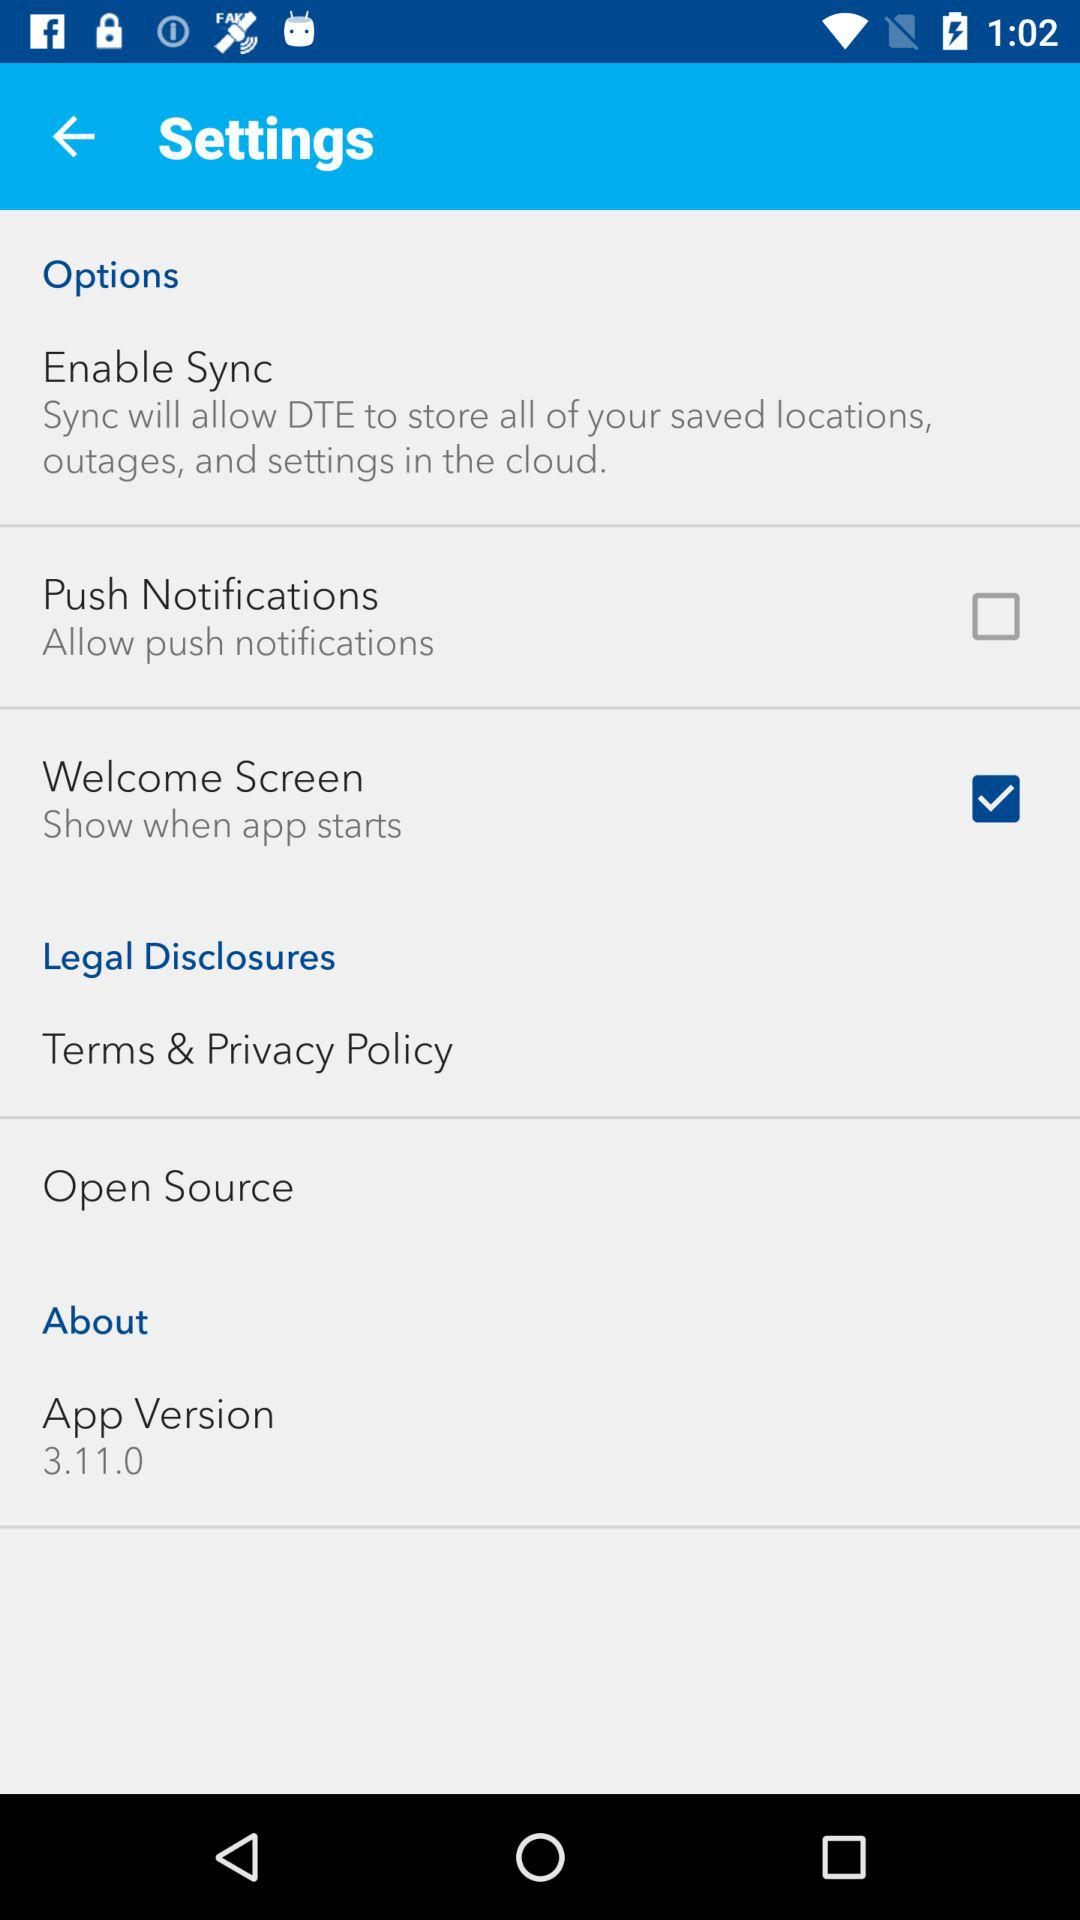Which option is checked in the settings? The checked option is "Welcome Screen". 